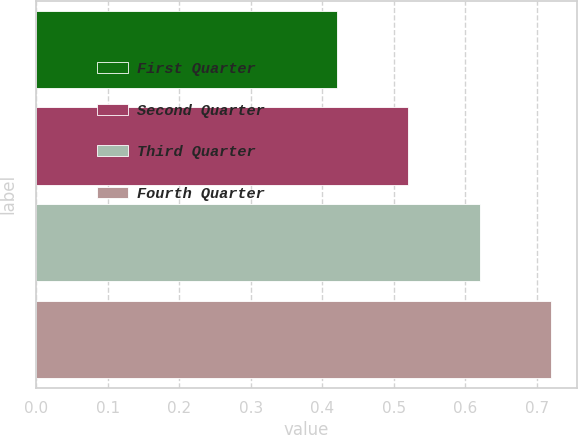Convert chart to OTSL. <chart><loc_0><loc_0><loc_500><loc_500><bar_chart><fcel>First Quarter<fcel>Second Quarter<fcel>Third Quarter<fcel>Fourth Quarter<nl><fcel>0.42<fcel>0.52<fcel>0.62<fcel>0.72<nl></chart> 